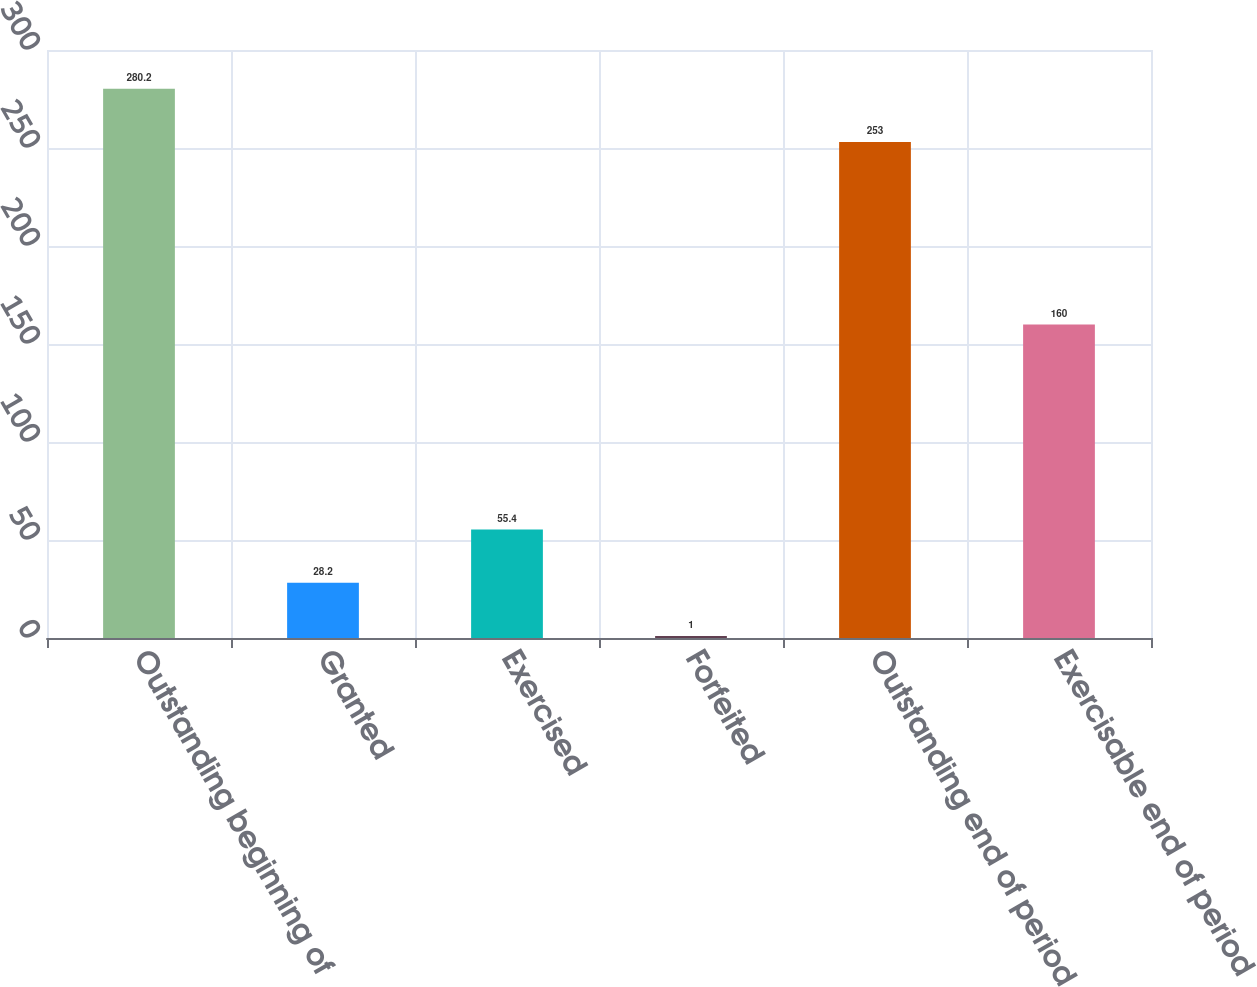Convert chart to OTSL. <chart><loc_0><loc_0><loc_500><loc_500><bar_chart><fcel>Outstanding beginning of<fcel>Granted<fcel>Exercised<fcel>Forfeited<fcel>Outstanding end of period<fcel>Exercisable end of period<nl><fcel>280.2<fcel>28.2<fcel>55.4<fcel>1<fcel>253<fcel>160<nl></chart> 